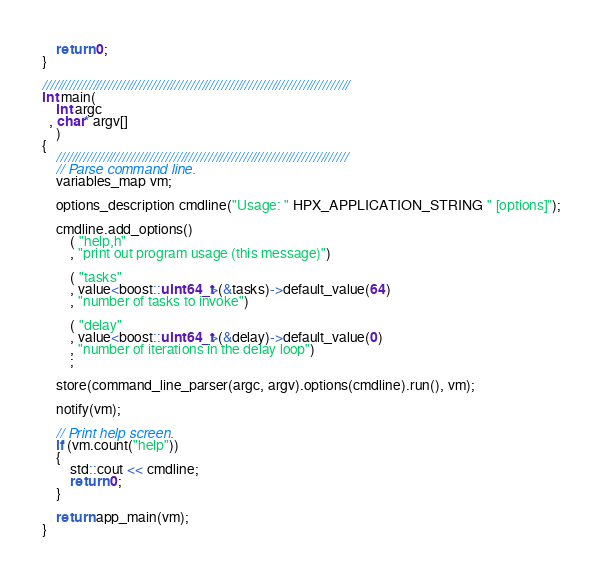Convert code to text. <code><loc_0><loc_0><loc_500><loc_500><_C++_>    return 0;
}

///////////////////////////////////////////////////////////////////////////////
int main(
    int argc
  , char* argv[]
    )
{
    ///////////////////////////////////////////////////////////////////////////
    // Parse command line.
    variables_map vm;

    options_description cmdline("Usage: " HPX_APPLICATION_STRING " [options]");

    cmdline.add_options()
        ( "help,h"
        , "print out program usage (this message)")

        ( "tasks"
        , value<boost::uint64_t>(&tasks)->default_value(64)
        , "number of tasks to invoke")

        ( "delay"
        , value<boost::uint64_t>(&delay)->default_value(0)
        , "number of iterations in the delay loop")
        ;

    store(command_line_parser(argc, argv).options(cmdline).run(), vm);

    notify(vm);

    // Print help screen.
    if (vm.count("help"))
    {
        std::cout << cmdline;
        return 0;
    }

    return app_main(vm);
}

</code> 